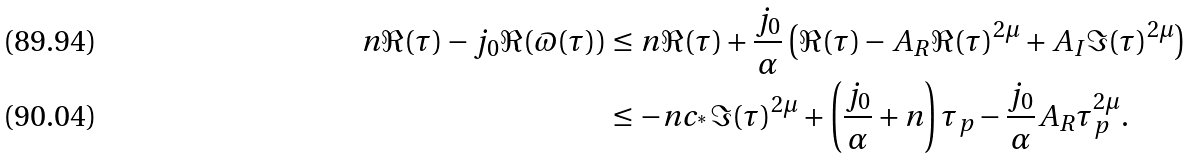<formula> <loc_0><loc_0><loc_500><loc_500>n \Re ( \tau ) - j _ { 0 } \Re ( \varpi ( \tau ) ) & \leq n \Re ( \tau ) + \frac { j _ { 0 } } { \alpha } \left ( \Re ( \tau ) - A _ { R } \Re ( \tau ) ^ { 2 \mu } + A _ { I } \Im ( \tau ) ^ { 2 \mu } \right ) \\ & \leq - n c _ { ^ { * } } \Im ( \tau ) ^ { 2 \mu } + \left ( \frac { j _ { 0 } } { \alpha } + n \right ) \tau _ { p } - \frac { j _ { 0 } } { \alpha } A _ { R } \tau _ { p } ^ { 2 \mu } .</formula> 